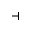<formula> <loc_0><loc_0><loc_500><loc_500>\dashv</formula> 